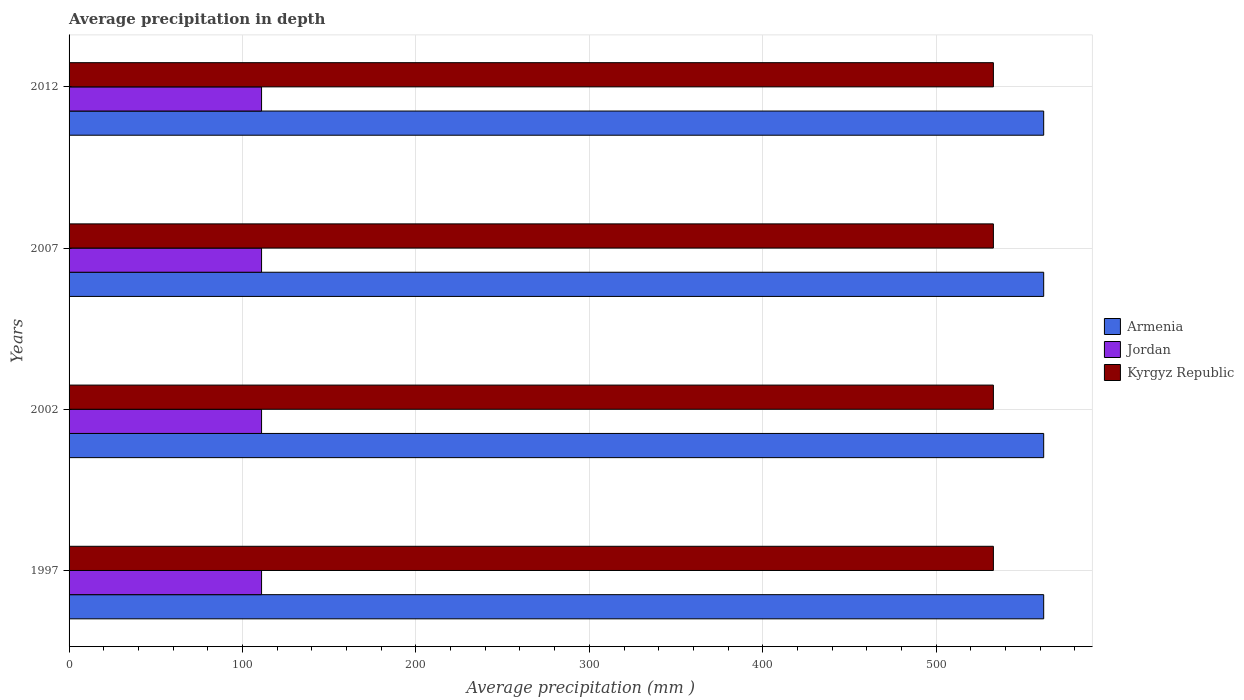Are the number of bars per tick equal to the number of legend labels?
Keep it short and to the point. Yes. Are the number of bars on each tick of the Y-axis equal?
Offer a terse response. Yes. What is the label of the 3rd group of bars from the top?
Provide a short and direct response. 2002. In how many cases, is the number of bars for a given year not equal to the number of legend labels?
Offer a terse response. 0. What is the average precipitation in Kyrgyz Republic in 2012?
Your answer should be compact. 533. Across all years, what is the maximum average precipitation in Kyrgyz Republic?
Keep it short and to the point. 533. Across all years, what is the minimum average precipitation in Jordan?
Provide a succinct answer. 111. In which year was the average precipitation in Kyrgyz Republic minimum?
Your answer should be compact. 1997. What is the total average precipitation in Armenia in the graph?
Provide a short and direct response. 2248. What is the difference between the average precipitation in Kyrgyz Republic in 1997 and the average precipitation in Jordan in 2002?
Ensure brevity in your answer.  422. What is the average average precipitation in Armenia per year?
Your answer should be very brief. 562. In the year 1997, what is the difference between the average precipitation in Jordan and average precipitation in Kyrgyz Republic?
Offer a terse response. -422. In how many years, is the average precipitation in Jordan greater than 340 mm?
Your answer should be compact. 0. Is the average precipitation in Kyrgyz Republic in 1997 less than that in 2002?
Your answer should be very brief. No. Is the difference between the average precipitation in Jordan in 1997 and 2007 greater than the difference between the average precipitation in Kyrgyz Republic in 1997 and 2007?
Offer a very short reply. No. What is the difference between the highest and the lowest average precipitation in Jordan?
Provide a short and direct response. 0. What does the 1st bar from the top in 2002 represents?
Give a very brief answer. Kyrgyz Republic. What does the 1st bar from the bottom in 2007 represents?
Give a very brief answer. Armenia. Is it the case that in every year, the sum of the average precipitation in Kyrgyz Republic and average precipitation in Armenia is greater than the average precipitation in Jordan?
Provide a short and direct response. Yes. How many bars are there?
Offer a very short reply. 12. Are all the bars in the graph horizontal?
Give a very brief answer. Yes. How many years are there in the graph?
Your answer should be compact. 4. What is the difference between two consecutive major ticks on the X-axis?
Ensure brevity in your answer.  100. Where does the legend appear in the graph?
Make the answer very short. Center right. How are the legend labels stacked?
Ensure brevity in your answer.  Vertical. What is the title of the graph?
Make the answer very short. Average precipitation in depth. What is the label or title of the X-axis?
Keep it short and to the point. Average precipitation (mm ). What is the Average precipitation (mm ) in Armenia in 1997?
Your response must be concise. 562. What is the Average precipitation (mm ) in Jordan in 1997?
Provide a short and direct response. 111. What is the Average precipitation (mm ) of Kyrgyz Republic in 1997?
Make the answer very short. 533. What is the Average precipitation (mm ) in Armenia in 2002?
Make the answer very short. 562. What is the Average precipitation (mm ) of Jordan in 2002?
Give a very brief answer. 111. What is the Average precipitation (mm ) in Kyrgyz Republic in 2002?
Offer a very short reply. 533. What is the Average precipitation (mm ) in Armenia in 2007?
Your response must be concise. 562. What is the Average precipitation (mm ) of Jordan in 2007?
Your answer should be very brief. 111. What is the Average precipitation (mm ) of Kyrgyz Republic in 2007?
Offer a terse response. 533. What is the Average precipitation (mm ) in Armenia in 2012?
Ensure brevity in your answer.  562. What is the Average precipitation (mm ) of Jordan in 2012?
Your answer should be very brief. 111. What is the Average precipitation (mm ) in Kyrgyz Republic in 2012?
Make the answer very short. 533. Across all years, what is the maximum Average precipitation (mm ) of Armenia?
Provide a succinct answer. 562. Across all years, what is the maximum Average precipitation (mm ) of Jordan?
Provide a succinct answer. 111. Across all years, what is the maximum Average precipitation (mm ) in Kyrgyz Republic?
Your answer should be very brief. 533. Across all years, what is the minimum Average precipitation (mm ) in Armenia?
Ensure brevity in your answer.  562. Across all years, what is the minimum Average precipitation (mm ) in Jordan?
Give a very brief answer. 111. Across all years, what is the minimum Average precipitation (mm ) in Kyrgyz Republic?
Provide a succinct answer. 533. What is the total Average precipitation (mm ) in Armenia in the graph?
Offer a terse response. 2248. What is the total Average precipitation (mm ) in Jordan in the graph?
Offer a terse response. 444. What is the total Average precipitation (mm ) in Kyrgyz Republic in the graph?
Give a very brief answer. 2132. What is the difference between the Average precipitation (mm ) in Armenia in 1997 and that in 2002?
Your response must be concise. 0. What is the difference between the Average precipitation (mm ) in Jordan in 1997 and that in 2002?
Offer a very short reply. 0. What is the difference between the Average precipitation (mm ) in Kyrgyz Republic in 1997 and that in 2002?
Your response must be concise. 0. What is the difference between the Average precipitation (mm ) of Kyrgyz Republic in 1997 and that in 2007?
Offer a terse response. 0. What is the difference between the Average precipitation (mm ) of Armenia in 1997 and that in 2012?
Give a very brief answer. 0. What is the difference between the Average precipitation (mm ) of Jordan in 1997 and that in 2012?
Give a very brief answer. 0. What is the difference between the Average precipitation (mm ) of Armenia in 2002 and that in 2007?
Offer a very short reply. 0. What is the difference between the Average precipitation (mm ) in Jordan in 2002 and that in 2007?
Your response must be concise. 0. What is the difference between the Average precipitation (mm ) in Jordan in 2002 and that in 2012?
Provide a succinct answer. 0. What is the difference between the Average precipitation (mm ) of Kyrgyz Republic in 2002 and that in 2012?
Ensure brevity in your answer.  0. What is the difference between the Average precipitation (mm ) in Kyrgyz Republic in 2007 and that in 2012?
Your response must be concise. 0. What is the difference between the Average precipitation (mm ) of Armenia in 1997 and the Average precipitation (mm ) of Jordan in 2002?
Provide a succinct answer. 451. What is the difference between the Average precipitation (mm ) of Armenia in 1997 and the Average precipitation (mm ) of Kyrgyz Republic in 2002?
Offer a very short reply. 29. What is the difference between the Average precipitation (mm ) in Jordan in 1997 and the Average precipitation (mm ) in Kyrgyz Republic in 2002?
Your answer should be compact. -422. What is the difference between the Average precipitation (mm ) in Armenia in 1997 and the Average precipitation (mm ) in Jordan in 2007?
Ensure brevity in your answer.  451. What is the difference between the Average precipitation (mm ) of Armenia in 1997 and the Average precipitation (mm ) of Kyrgyz Republic in 2007?
Give a very brief answer. 29. What is the difference between the Average precipitation (mm ) in Jordan in 1997 and the Average precipitation (mm ) in Kyrgyz Republic in 2007?
Provide a succinct answer. -422. What is the difference between the Average precipitation (mm ) of Armenia in 1997 and the Average precipitation (mm ) of Jordan in 2012?
Offer a very short reply. 451. What is the difference between the Average precipitation (mm ) of Armenia in 1997 and the Average precipitation (mm ) of Kyrgyz Republic in 2012?
Your answer should be compact. 29. What is the difference between the Average precipitation (mm ) in Jordan in 1997 and the Average precipitation (mm ) in Kyrgyz Republic in 2012?
Your answer should be compact. -422. What is the difference between the Average precipitation (mm ) of Armenia in 2002 and the Average precipitation (mm ) of Jordan in 2007?
Make the answer very short. 451. What is the difference between the Average precipitation (mm ) of Armenia in 2002 and the Average precipitation (mm ) of Kyrgyz Republic in 2007?
Your answer should be compact. 29. What is the difference between the Average precipitation (mm ) in Jordan in 2002 and the Average precipitation (mm ) in Kyrgyz Republic in 2007?
Offer a very short reply. -422. What is the difference between the Average precipitation (mm ) of Armenia in 2002 and the Average precipitation (mm ) of Jordan in 2012?
Keep it short and to the point. 451. What is the difference between the Average precipitation (mm ) in Jordan in 2002 and the Average precipitation (mm ) in Kyrgyz Republic in 2012?
Offer a very short reply. -422. What is the difference between the Average precipitation (mm ) of Armenia in 2007 and the Average precipitation (mm ) of Jordan in 2012?
Offer a terse response. 451. What is the difference between the Average precipitation (mm ) of Jordan in 2007 and the Average precipitation (mm ) of Kyrgyz Republic in 2012?
Offer a very short reply. -422. What is the average Average precipitation (mm ) in Armenia per year?
Your response must be concise. 562. What is the average Average precipitation (mm ) in Jordan per year?
Give a very brief answer. 111. What is the average Average precipitation (mm ) of Kyrgyz Republic per year?
Give a very brief answer. 533. In the year 1997, what is the difference between the Average precipitation (mm ) of Armenia and Average precipitation (mm ) of Jordan?
Provide a short and direct response. 451. In the year 1997, what is the difference between the Average precipitation (mm ) of Armenia and Average precipitation (mm ) of Kyrgyz Republic?
Your answer should be very brief. 29. In the year 1997, what is the difference between the Average precipitation (mm ) of Jordan and Average precipitation (mm ) of Kyrgyz Republic?
Your response must be concise. -422. In the year 2002, what is the difference between the Average precipitation (mm ) in Armenia and Average precipitation (mm ) in Jordan?
Ensure brevity in your answer.  451. In the year 2002, what is the difference between the Average precipitation (mm ) in Armenia and Average precipitation (mm ) in Kyrgyz Republic?
Ensure brevity in your answer.  29. In the year 2002, what is the difference between the Average precipitation (mm ) of Jordan and Average precipitation (mm ) of Kyrgyz Republic?
Your response must be concise. -422. In the year 2007, what is the difference between the Average precipitation (mm ) in Armenia and Average precipitation (mm ) in Jordan?
Your response must be concise. 451. In the year 2007, what is the difference between the Average precipitation (mm ) in Armenia and Average precipitation (mm ) in Kyrgyz Republic?
Give a very brief answer. 29. In the year 2007, what is the difference between the Average precipitation (mm ) in Jordan and Average precipitation (mm ) in Kyrgyz Republic?
Your response must be concise. -422. In the year 2012, what is the difference between the Average precipitation (mm ) in Armenia and Average precipitation (mm ) in Jordan?
Your response must be concise. 451. In the year 2012, what is the difference between the Average precipitation (mm ) of Armenia and Average precipitation (mm ) of Kyrgyz Republic?
Offer a terse response. 29. In the year 2012, what is the difference between the Average precipitation (mm ) of Jordan and Average precipitation (mm ) of Kyrgyz Republic?
Offer a terse response. -422. What is the ratio of the Average precipitation (mm ) in Armenia in 1997 to that in 2002?
Give a very brief answer. 1. What is the ratio of the Average precipitation (mm ) in Jordan in 1997 to that in 2002?
Your response must be concise. 1. What is the ratio of the Average precipitation (mm ) of Armenia in 1997 to that in 2007?
Offer a terse response. 1. What is the ratio of the Average precipitation (mm ) of Jordan in 1997 to that in 2007?
Your answer should be very brief. 1. What is the ratio of the Average precipitation (mm ) in Armenia in 1997 to that in 2012?
Provide a succinct answer. 1. What is the ratio of the Average precipitation (mm ) in Jordan in 1997 to that in 2012?
Provide a succinct answer. 1. What is the ratio of the Average precipitation (mm ) of Jordan in 2002 to that in 2012?
Your answer should be very brief. 1. What is the ratio of the Average precipitation (mm ) of Jordan in 2007 to that in 2012?
Give a very brief answer. 1. What is the difference between the highest and the second highest Average precipitation (mm ) in Armenia?
Your response must be concise. 0. What is the difference between the highest and the second highest Average precipitation (mm ) of Kyrgyz Republic?
Keep it short and to the point. 0. What is the difference between the highest and the lowest Average precipitation (mm ) in Kyrgyz Republic?
Your response must be concise. 0. 